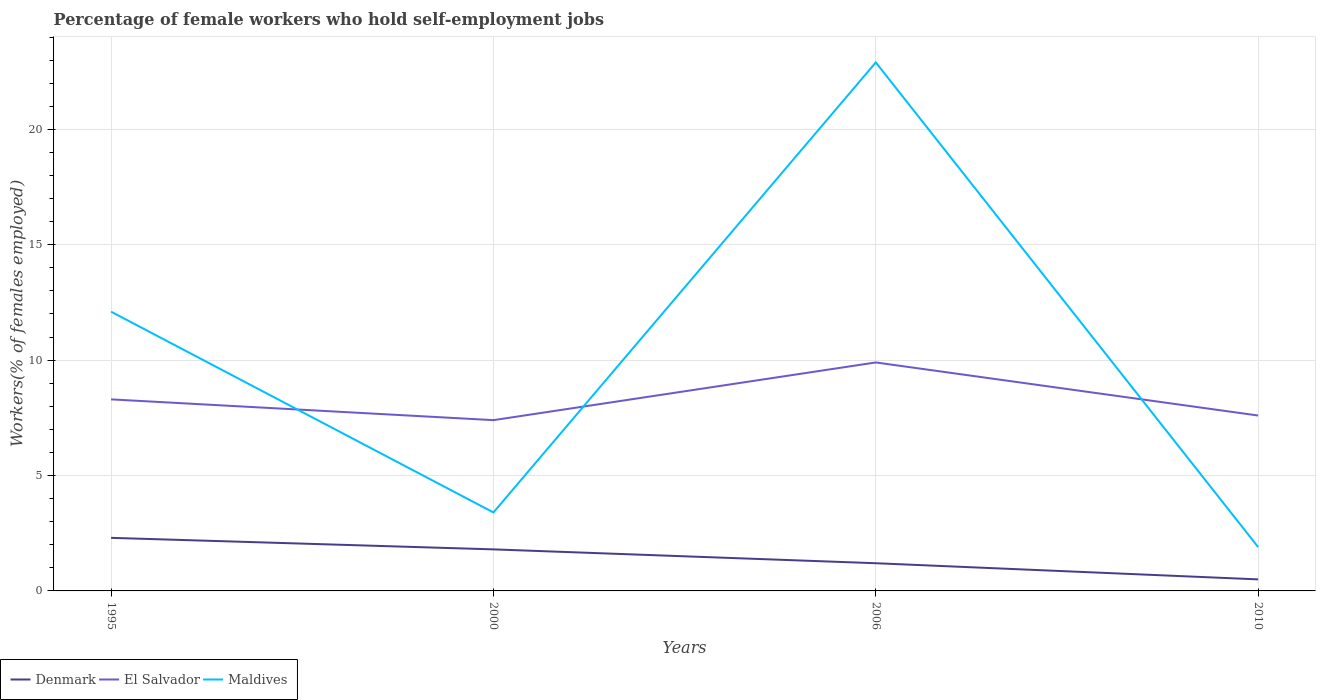Does the line corresponding to El Salvador intersect with the line corresponding to Maldives?
Keep it short and to the point. Yes. Is the number of lines equal to the number of legend labels?
Offer a terse response. Yes. Across all years, what is the maximum percentage of self-employed female workers in El Salvador?
Offer a very short reply. 7.4. In which year was the percentage of self-employed female workers in Maldives maximum?
Provide a succinct answer. 2010. What is the total percentage of self-employed female workers in El Salvador in the graph?
Provide a succinct answer. -0.2. What is the difference between the highest and the second highest percentage of self-employed female workers in El Salvador?
Your response must be concise. 2.5. Is the percentage of self-employed female workers in Maldives strictly greater than the percentage of self-employed female workers in El Salvador over the years?
Make the answer very short. No. How many years are there in the graph?
Provide a short and direct response. 4. Does the graph contain any zero values?
Provide a short and direct response. No. Does the graph contain grids?
Your answer should be compact. Yes. What is the title of the graph?
Keep it short and to the point. Percentage of female workers who hold self-employment jobs. Does "Samoa" appear as one of the legend labels in the graph?
Your response must be concise. No. What is the label or title of the Y-axis?
Offer a terse response. Workers(% of females employed). What is the Workers(% of females employed) in Denmark in 1995?
Make the answer very short. 2.3. What is the Workers(% of females employed) of El Salvador in 1995?
Your response must be concise. 8.3. What is the Workers(% of females employed) of Maldives in 1995?
Provide a succinct answer. 12.1. What is the Workers(% of females employed) in Denmark in 2000?
Provide a succinct answer. 1.8. What is the Workers(% of females employed) in El Salvador in 2000?
Offer a terse response. 7.4. What is the Workers(% of females employed) in Maldives in 2000?
Keep it short and to the point. 3.4. What is the Workers(% of females employed) of Denmark in 2006?
Give a very brief answer. 1.2. What is the Workers(% of females employed) in El Salvador in 2006?
Provide a succinct answer. 9.9. What is the Workers(% of females employed) of Maldives in 2006?
Offer a very short reply. 22.9. What is the Workers(% of females employed) of Denmark in 2010?
Keep it short and to the point. 0.5. What is the Workers(% of females employed) in El Salvador in 2010?
Keep it short and to the point. 7.6. What is the Workers(% of females employed) of Maldives in 2010?
Your answer should be very brief. 1.9. Across all years, what is the maximum Workers(% of females employed) of Denmark?
Your answer should be compact. 2.3. Across all years, what is the maximum Workers(% of females employed) of El Salvador?
Offer a terse response. 9.9. Across all years, what is the maximum Workers(% of females employed) of Maldives?
Your response must be concise. 22.9. Across all years, what is the minimum Workers(% of females employed) in Denmark?
Your response must be concise. 0.5. Across all years, what is the minimum Workers(% of females employed) of El Salvador?
Make the answer very short. 7.4. Across all years, what is the minimum Workers(% of females employed) in Maldives?
Your answer should be compact. 1.9. What is the total Workers(% of females employed) of Denmark in the graph?
Your response must be concise. 5.8. What is the total Workers(% of females employed) in El Salvador in the graph?
Provide a short and direct response. 33.2. What is the total Workers(% of females employed) in Maldives in the graph?
Provide a short and direct response. 40.3. What is the difference between the Workers(% of females employed) in Denmark in 1995 and that in 2000?
Provide a succinct answer. 0.5. What is the difference between the Workers(% of females employed) of Maldives in 1995 and that in 2000?
Give a very brief answer. 8.7. What is the difference between the Workers(% of females employed) in El Salvador in 1995 and that in 2006?
Provide a succinct answer. -1.6. What is the difference between the Workers(% of females employed) of Denmark in 1995 and that in 2010?
Give a very brief answer. 1.8. What is the difference between the Workers(% of females employed) in Denmark in 2000 and that in 2006?
Your answer should be very brief. 0.6. What is the difference between the Workers(% of females employed) of Maldives in 2000 and that in 2006?
Ensure brevity in your answer.  -19.5. What is the difference between the Workers(% of females employed) of Denmark in 2000 and that in 2010?
Your response must be concise. 1.3. What is the difference between the Workers(% of females employed) in Maldives in 2000 and that in 2010?
Your answer should be very brief. 1.5. What is the difference between the Workers(% of females employed) in Maldives in 2006 and that in 2010?
Offer a very short reply. 21. What is the difference between the Workers(% of females employed) in Denmark in 1995 and the Workers(% of females employed) in El Salvador in 2000?
Make the answer very short. -5.1. What is the difference between the Workers(% of females employed) in Denmark in 1995 and the Workers(% of females employed) in Maldives in 2000?
Provide a short and direct response. -1.1. What is the difference between the Workers(% of females employed) in El Salvador in 1995 and the Workers(% of females employed) in Maldives in 2000?
Your answer should be compact. 4.9. What is the difference between the Workers(% of females employed) of Denmark in 1995 and the Workers(% of females employed) of Maldives in 2006?
Provide a short and direct response. -20.6. What is the difference between the Workers(% of females employed) of El Salvador in 1995 and the Workers(% of females employed) of Maldives in 2006?
Provide a succinct answer. -14.6. What is the difference between the Workers(% of females employed) in Denmark in 1995 and the Workers(% of females employed) in Maldives in 2010?
Provide a succinct answer. 0.4. What is the difference between the Workers(% of females employed) of Denmark in 2000 and the Workers(% of females employed) of Maldives in 2006?
Provide a short and direct response. -21.1. What is the difference between the Workers(% of females employed) of El Salvador in 2000 and the Workers(% of females employed) of Maldives in 2006?
Provide a succinct answer. -15.5. What is the difference between the Workers(% of females employed) in El Salvador in 2000 and the Workers(% of females employed) in Maldives in 2010?
Keep it short and to the point. 5.5. What is the difference between the Workers(% of females employed) of Denmark in 2006 and the Workers(% of females employed) of El Salvador in 2010?
Your response must be concise. -6.4. What is the difference between the Workers(% of females employed) in El Salvador in 2006 and the Workers(% of females employed) in Maldives in 2010?
Provide a short and direct response. 8. What is the average Workers(% of females employed) in Denmark per year?
Make the answer very short. 1.45. What is the average Workers(% of females employed) of El Salvador per year?
Make the answer very short. 8.3. What is the average Workers(% of females employed) of Maldives per year?
Give a very brief answer. 10.07. In the year 1995, what is the difference between the Workers(% of females employed) in Denmark and Workers(% of females employed) in El Salvador?
Your answer should be compact. -6. In the year 2006, what is the difference between the Workers(% of females employed) in Denmark and Workers(% of females employed) in El Salvador?
Provide a short and direct response. -8.7. In the year 2006, what is the difference between the Workers(% of females employed) of Denmark and Workers(% of females employed) of Maldives?
Make the answer very short. -21.7. In the year 2006, what is the difference between the Workers(% of females employed) of El Salvador and Workers(% of females employed) of Maldives?
Your answer should be very brief. -13. In the year 2010, what is the difference between the Workers(% of females employed) of El Salvador and Workers(% of females employed) of Maldives?
Make the answer very short. 5.7. What is the ratio of the Workers(% of females employed) in Denmark in 1995 to that in 2000?
Ensure brevity in your answer.  1.28. What is the ratio of the Workers(% of females employed) in El Salvador in 1995 to that in 2000?
Provide a short and direct response. 1.12. What is the ratio of the Workers(% of females employed) in Maldives in 1995 to that in 2000?
Keep it short and to the point. 3.56. What is the ratio of the Workers(% of females employed) in Denmark in 1995 to that in 2006?
Ensure brevity in your answer.  1.92. What is the ratio of the Workers(% of females employed) of El Salvador in 1995 to that in 2006?
Make the answer very short. 0.84. What is the ratio of the Workers(% of females employed) in Maldives in 1995 to that in 2006?
Offer a terse response. 0.53. What is the ratio of the Workers(% of females employed) in Denmark in 1995 to that in 2010?
Give a very brief answer. 4.6. What is the ratio of the Workers(% of females employed) in El Salvador in 1995 to that in 2010?
Keep it short and to the point. 1.09. What is the ratio of the Workers(% of females employed) of Maldives in 1995 to that in 2010?
Provide a succinct answer. 6.37. What is the ratio of the Workers(% of females employed) of Denmark in 2000 to that in 2006?
Provide a succinct answer. 1.5. What is the ratio of the Workers(% of females employed) of El Salvador in 2000 to that in 2006?
Offer a terse response. 0.75. What is the ratio of the Workers(% of females employed) in Maldives in 2000 to that in 2006?
Keep it short and to the point. 0.15. What is the ratio of the Workers(% of females employed) in El Salvador in 2000 to that in 2010?
Your response must be concise. 0.97. What is the ratio of the Workers(% of females employed) of Maldives in 2000 to that in 2010?
Offer a terse response. 1.79. What is the ratio of the Workers(% of females employed) in El Salvador in 2006 to that in 2010?
Provide a succinct answer. 1.3. What is the ratio of the Workers(% of females employed) of Maldives in 2006 to that in 2010?
Offer a terse response. 12.05. What is the difference between the highest and the lowest Workers(% of females employed) of Denmark?
Offer a terse response. 1.8. What is the difference between the highest and the lowest Workers(% of females employed) in El Salvador?
Offer a terse response. 2.5. What is the difference between the highest and the lowest Workers(% of females employed) in Maldives?
Your answer should be compact. 21. 